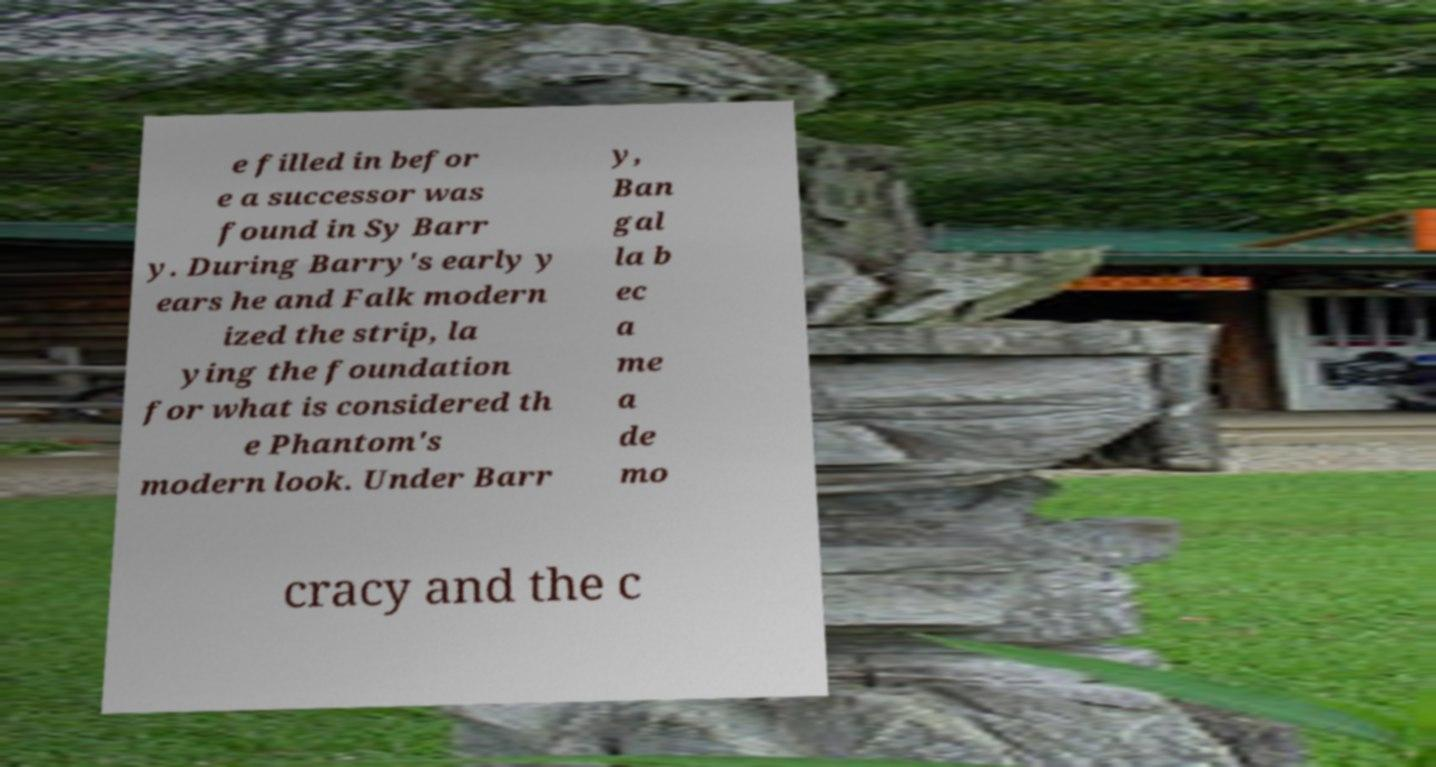Please read and relay the text visible in this image. What does it say? e filled in befor e a successor was found in Sy Barr y. During Barry's early y ears he and Falk modern ized the strip, la ying the foundation for what is considered th e Phantom's modern look. Under Barr y, Ban gal la b ec a me a de mo cracy and the c 